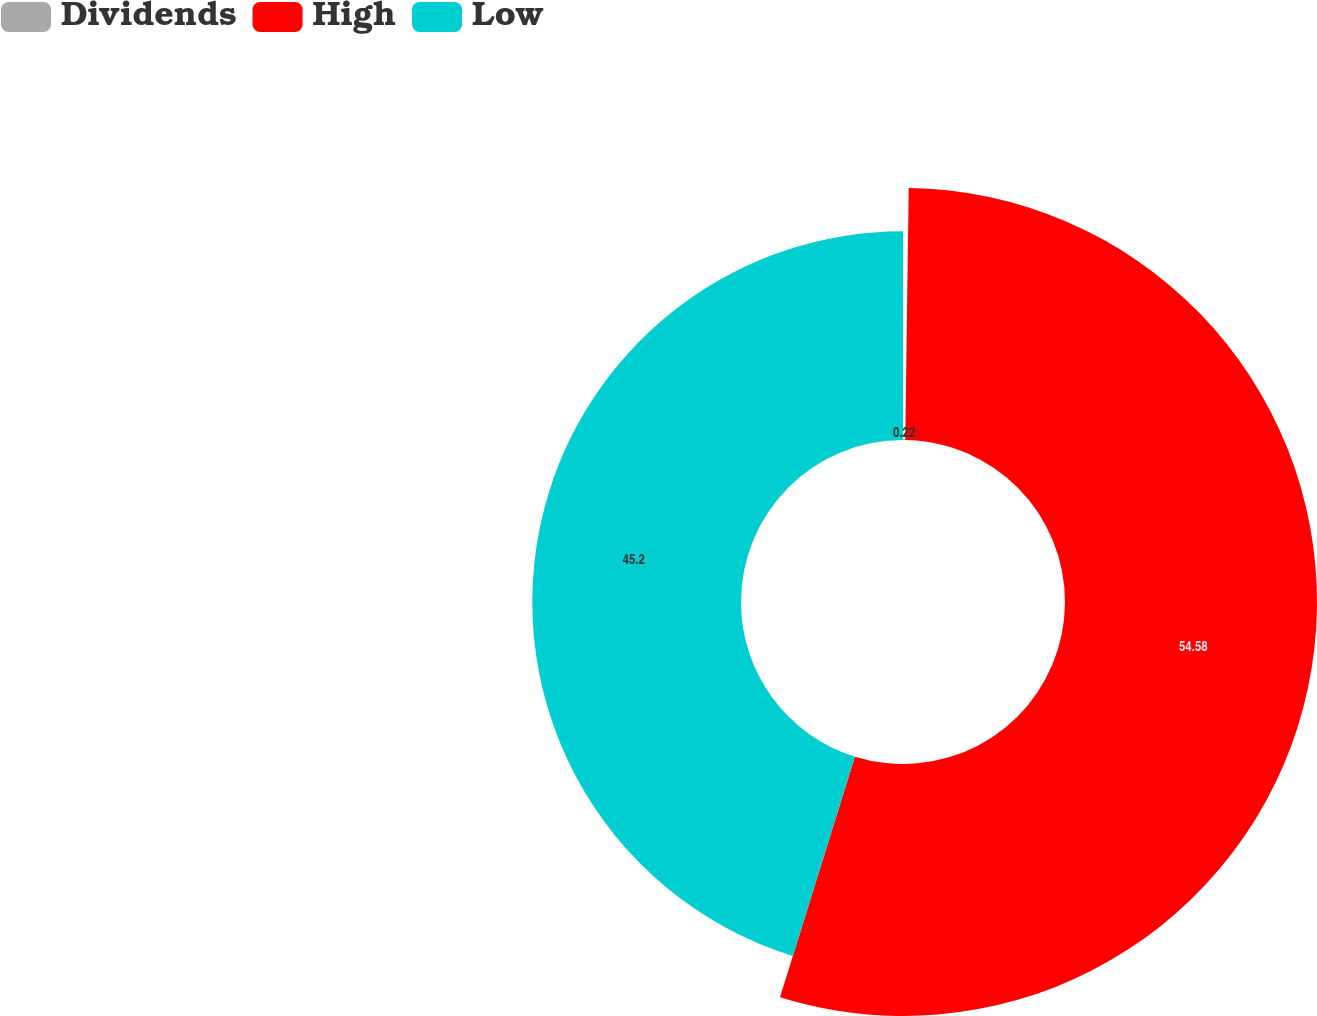Convert chart. <chart><loc_0><loc_0><loc_500><loc_500><pie_chart><fcel>Dividends<fcel>High<fcel>Low<nl><fcel>0.22%<fcel>54.58%<fcel>45.2%<nl></chart> 